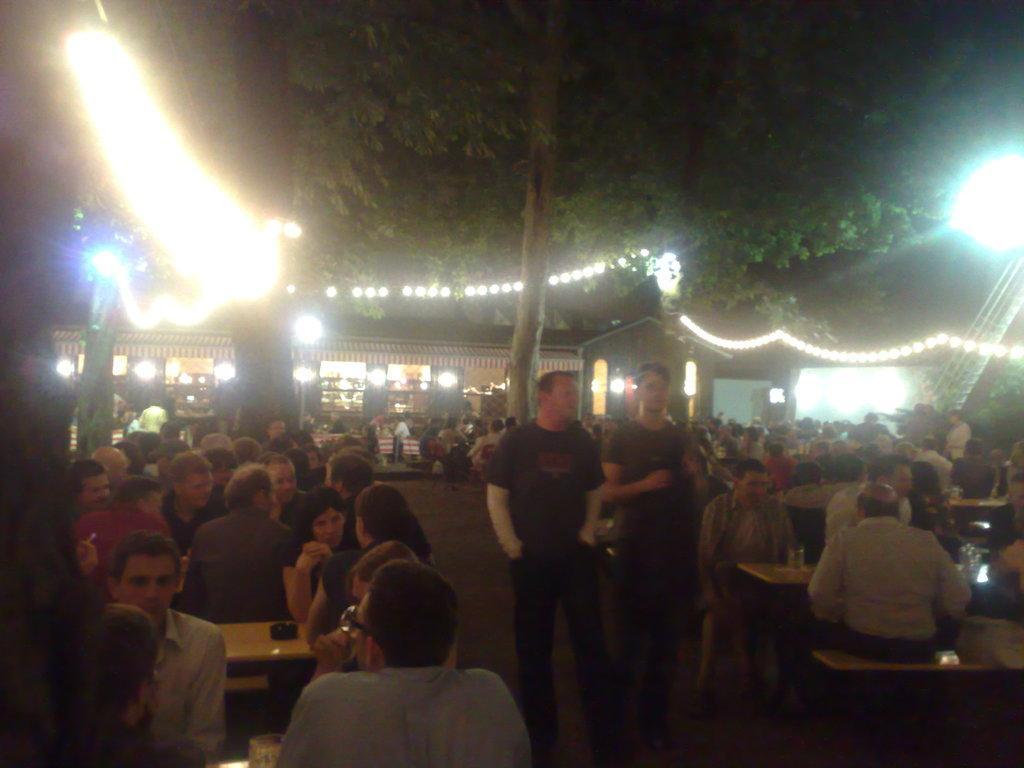Can you describe this image briefly? In this picture we can see some people sitting in front of tables, there are two person walking in the front, in the background there are some lights, we can see a tree in the middle. 